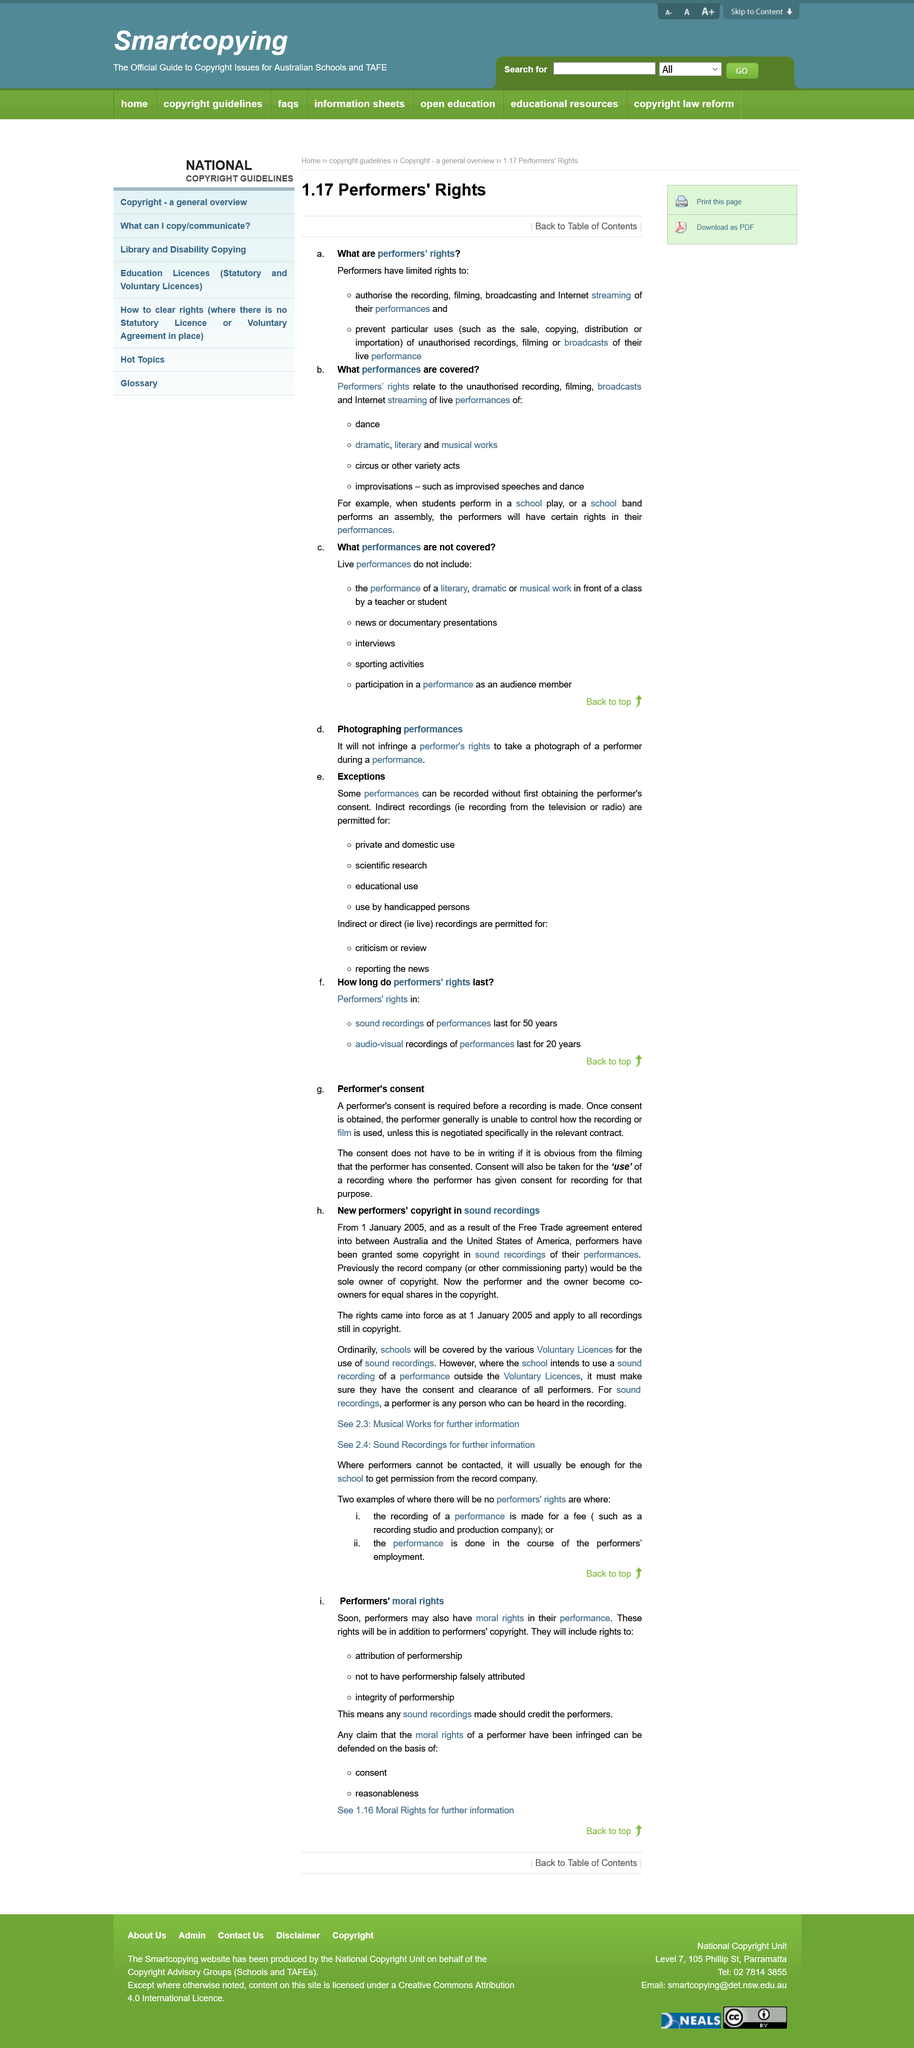Mention a couple of crucial points in this snapshot. The performer and the record company share the copyright from January 2005. Once performer consent has been obtained according to the topic of performer's consent, the performer is unable to control how the recording or film of their performance is used. It is hereby declared that consent will also be taken for the 'use' of a recording where the performer has given prior consent for the specific purpose of the recording. It is required that a performer's consent be obtained before a recording is made. The result of the Free Trade agreement applies to all recordings that are still in copyright, regardless of whether they were made before or after the agreement was reached. 